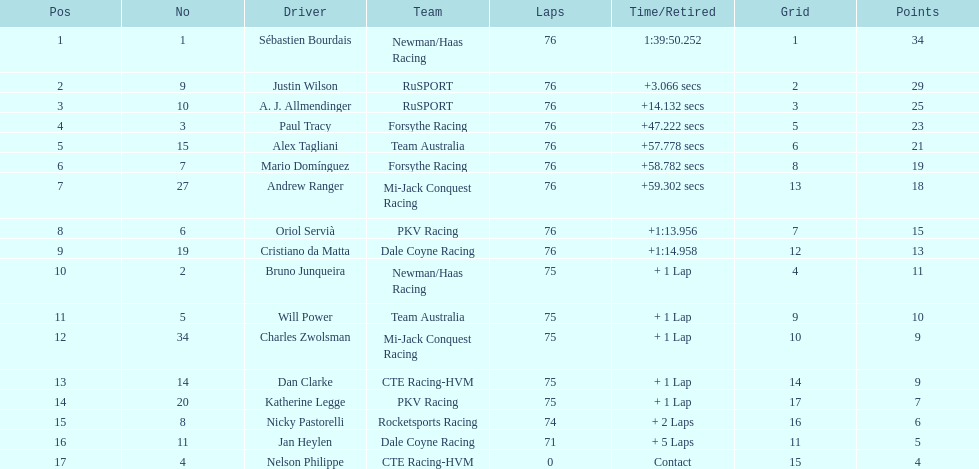How many brazilian drivers were involved in the competition? 2. Could you parse the entire table as a dict? {'header': ['Pos', 'No', 'Driver', 'Team', 'Laps', 'Time/Retired', 'Grid', 'Points'], 'rows': [['1', '1', 'Sébastien Bourdais', 'Newman/Haas Racing', '76', '1:39:50.252', '1', '34'], ['2', '9', 'Justin Wilson', 'RuSPORT', '76', '+3.066 secs', '2', '29'], ['3', '10', 'A. J. Allmendinger', 'RuSPORT', '76', '+14.132 secs', '3', '25'], ['4', '3', 'Paul Tracy', 'Forsythe Racing', '76', '+47.222 secs', '5', '23'], ['5', '15', 'Alex Tagliani', 'Team Australia', '76', '+57.778 secs', '6', '21'], ['6', '7', 'Mario Domínguez', 'Forsythe Racing', '76', '+58.782 secs', '8', '19'], ['7', '27', 'Andrew Ranger', 'Mi-Jack Conquest Racing', '76', '+59.302 secs', '13', '18'], ['8', '6', 'Oriol Servià', 'PKV Racing', '76', '+1:13.956', '7', '15'], ['9', '19', 'Cristiano da Matta', 'Dale Coyne Racing', '76', '+1:14.958', '12', '13'], ['10', '2', 'Bruno Junqueira', 'Newman/Haas Racing', '75', '+ 1 Lap', '4', '11'], ['11', '5', 'Will Power', 'Team Australia', '75', '+ 1 Lap', '9', '10'], ['12', '34', 'Charles Zwolsman', 'Mi-Jack Conquest Racing', '75', '+ 1 Lap', '10', '9'], ['13', '14', 'Dan Clarke', 'CTE Racing-HVM', '75', '+ 1 Lap', '14', '9'], ['14', '20', 'Katherine Legge', 'PKV Racing', '75', '+ 1 Lap', '17', '7'], ['15', '8', 'Nicky Pastorelli', 'Rocketsports Racing', '74', '+ 2 Laps', '16', '6'], ['16', '11', 'Jan Heylen', 'Dale Coyne Racing', '71', '+ 5 Laps', '11', '5'], ['17', '4', 'Nelson Philippe', 'CTE Racing-HVM', '0', 'Contact', '15', '4']]} 